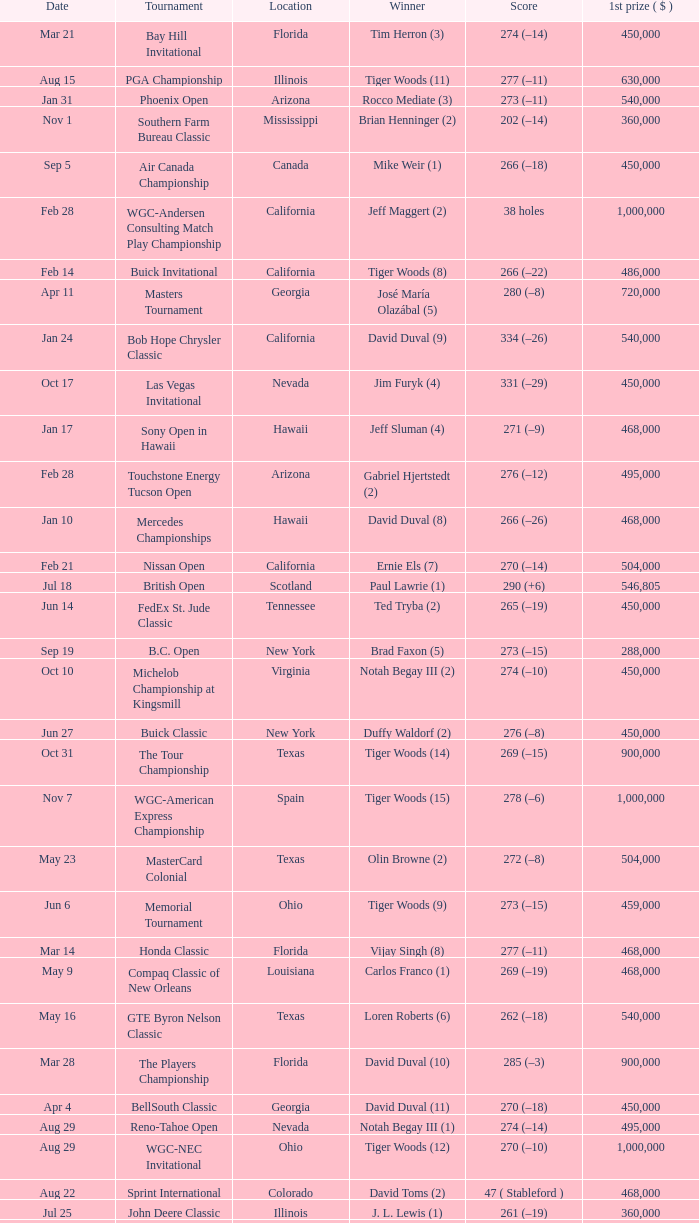Parse the table in full. {'header': ['Date', 'Tournament', 'Location', 'Winner', 'Score', '1st prize ( $ )'], 'rows': [['Mar 21', 'Bay Hill Invitational', 'Florida', 'Tim Herron (3)', '274 (–14)', '450,000'], ['Aug 15', 'PGA Championship', 'Illinois', 'Tiger Woods (11)', '277 (–11)', '630,000'], ['Jan 31', 'Phoenix Open', 'Arizona', 'Rocco Mediate (3)', '273 (–11)', '540,000'], ['Nov 1', 'Southern Farm Bureau Classic', 'Mississippi', 'Brian Henninger (2)', '202 (–14)', '360,000'], ['Sep 5', 'Air Canada Championship', 'Canada', 'Mike Weir (1)', '266 (–18)', '450,000'], ['Feb 28', 'WGC-Andersen Consulting Match Play Championship', 'California', 'Jeff Maggert (2)', '38 holes', '1,000,000'], ['Feb 14', 'Buick Invitational', 'California', 'Tiger Woods (8)', '266 (–22)', '486,000'], ['Apr 11', 'Masters Tournament', 'Georgia', 'José María Olazábal (5)', '280 (–8)', '720,000'], ['Jan 24', 'Bob Hope Chrysler Classic', 'California', 'David Duval (9)', '334 (–26)', '540,000'], ['Oct 17', 'Las Vegas Invitational', 'Nevada', 'Jim Furyk (4)', '331 (–29)', '450,000'], ['Jan 17', 'Sony Open in Hawaii', 'Hawaii', 'Jeff Sluman (4)', '271 (–9)', '468,000'], ['Feb 28', 'Touchstone Energy Tucson Open', 'Arizona', 'Gabriel Hjertstedt (2)', '276 (–12)', '495,000'], ['Jan 10', 'Mercedes Championships', 'Hawaii', 'David Duval (8)', '266 (–26)', '468,000'], ['Feb 21', 'Nissan Open', 'California', 'Ernie Els (7)', '270 (–14)', '504,000'], ['Jul 18', 'British Open', 'Scotland', 'Paul Lawrie (1)', '290 (+6)', '546,805'], ['Jun 14', 'FedEx St. Jude Classic', 'Tennessee', 'Ted Tryba (2)', '265 (–19)', '450,000'], ['Sep 19', 'B.C. Open', 'New York', 'Brad Faxon (5)', '273 (–15)', '288,000'], ['Oct 10', 'Michelob Championship at Kingsmill', 'Virginia', 'Notah Begay III (2)', '274 (–10)', '450,000'], ['Jun 27', 'Buick Classic', 'New York', 'Duffy Waldorf (2)', '276 (–8)', '450,000'], ['Oct 31', 'The Tour Championship', 'Texas', 'Tiger Woods (14)', '269 (–15)', '900,000'], ['Nov 7', 'WGC-American Express Championship', 'Spain', 'Tiger Woods (15)', '278 (–6)', '1,000,000'], ['May 23', 'MasterCard Colonial', 'Texas', 'Olin Browne (2)', '272 (–8)', '504,000'], ['Jun 6', 'Memorial Tournament', 'Ohio', 'Tiger Woods (9)', '273 (–15)', '459,000'], ['Mar 14', 'Honda Classic', 'Florida', 'Vijay Singh (8)', '277 (–11)', '468,000'], ['May 9', 'Compaq Classic of New Orleans', 'Louisiana', 'Carlos Franco (1)', '269 (–19)', '468,000'], ['May 16', 'GTE Byron Nelson Classic', 'Texas', 'Loren Roberts (6)', '262 (–18)', '540,000'], ['Mar 28', 'The Players Championship', 'Florida', 'David Duval (10)', '285 (–3)', '900,000'], ['Apr 4', 'BellSouth Classic', 'Georgia', 'David Duval (11)', '270 (–18)', '450,000'], ['Aug 29', 'Reno-Tahoe Open', 'Nevada', 'Notah Begay III (1)', '274 (–14)', '495,000'], ['Aug 29', 'WGC-NEC Invitational', 'Ohio', 'Tiger Woods (12)', '270 (–10)', '1,000,000'], ['Aug 22', 'Sprint International', 'Colorado', 'David Toms (2)', '47 ( Stableford )', '468,000'], ['Jul 25', 'John Deere Classic', 'Illinois', 'J. L. Lewis (1)', '261 (–19)', '360,000'], ['Apr 25', 'Greater Greensboro Chrysler Classic', 'North Carolina', 'Jesper Parnevik (2)', '265 (–23)', '468,000'], ['Jul 4', 'Motorola Western Open', 'Illinois', 'Tiger Woods (10)', '273 (–15)', '450,000'], ['Jul 11', 'Greater Milwaukee Open', 'Wisconsin', 'Carlos Franco (2)', '264 (–20)', '414,000'], ['Apr 18', 'MCI Classic', 'South Carolina', 'Glen Day (1)', '274 (–10)', '450,000'], ['Oct 3', 'Buick Challenge', 'Georgia', 'David Toms (3)', '271 (–17)', '324,000'], ['Mar 7', 'Doral-Ryder Open', 'Florida', 'Steve Elkington (10)', '275 (–13)', '540,000'], ['Aug 8', 'Buick Open', 'Michigan', 'Tom Pernice, Jr. (1)', '270 (–18)', '432,000'], ['Oct 24', 'National Car Rental Golf Classic Disney', 'Florida', 'Tiger Woods (13)', '271 (–17)', '450,000'], ['Sep 12', 'Bell Canadian Open', 'Canada', 'Hal Sutton (11)', '275 (–13)', '450,000'], ['Aug 1', 'Canon Greater Hartford Open', 'Connecticut', 'Brent Geiberger (1)', '262 (–18)', '450,000'], ['Feb 7', 'AT&T Pebble Beach National Pro-Am', 'California', 'Payne Stewart (10)', '206 (–10)', '504,000'], ['May 2', 'Shell Houston Open', 'Texas', 'Stuart Appleby (3)', '279 (–9)', '450,000'], ['May 30', 'Kemper Open', 'Maryland', 'Rich Beem (1)', '274 (–10)', '450,000'], ['Jun 20', 'U.S. Open', 'North Carolina', 'Payne Stewart (11)', '279 (–1)', '625,000'], ['Sep 26', 'Westin Texas Open', 'Texas', 'Duffy Waldorf (3)', '270 (–18)', '360,000']]} What is the date of the Greater Greensboro Chrysler Classic? Apr 25. 